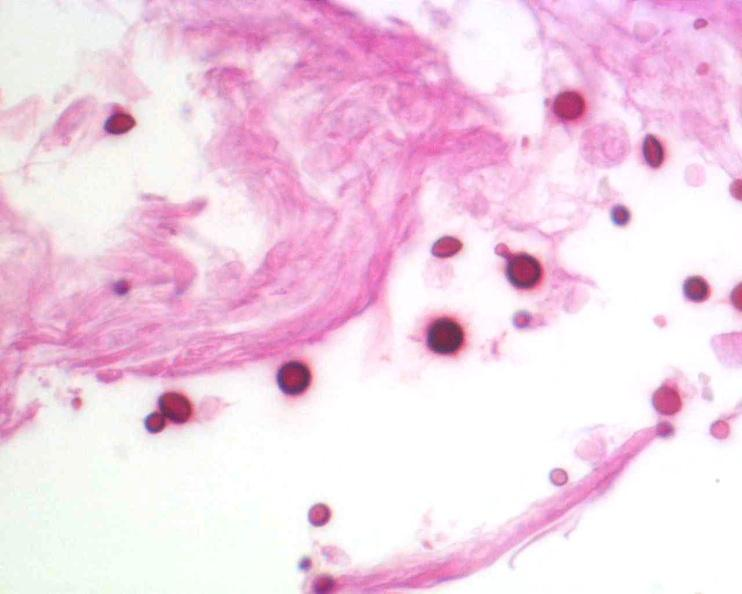does peritoneal fluid stain?
Answer the question using a single word or phrase. No 